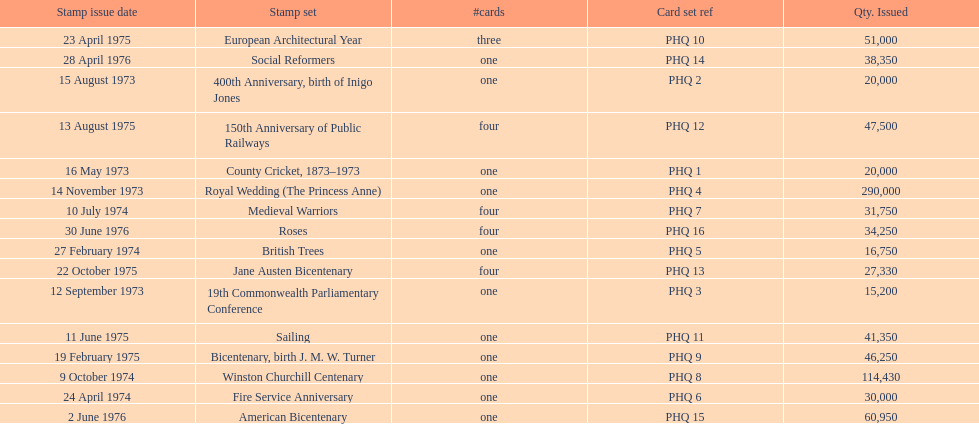Which was the only stamp set to have more than 200,000 issued? Royal Wedding (The Princess Anne). 